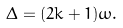<formula> <loc_0><loc_0><loc_500><loc_500>\Delta = ( 2 k + 1 ) \omega .</formula> 